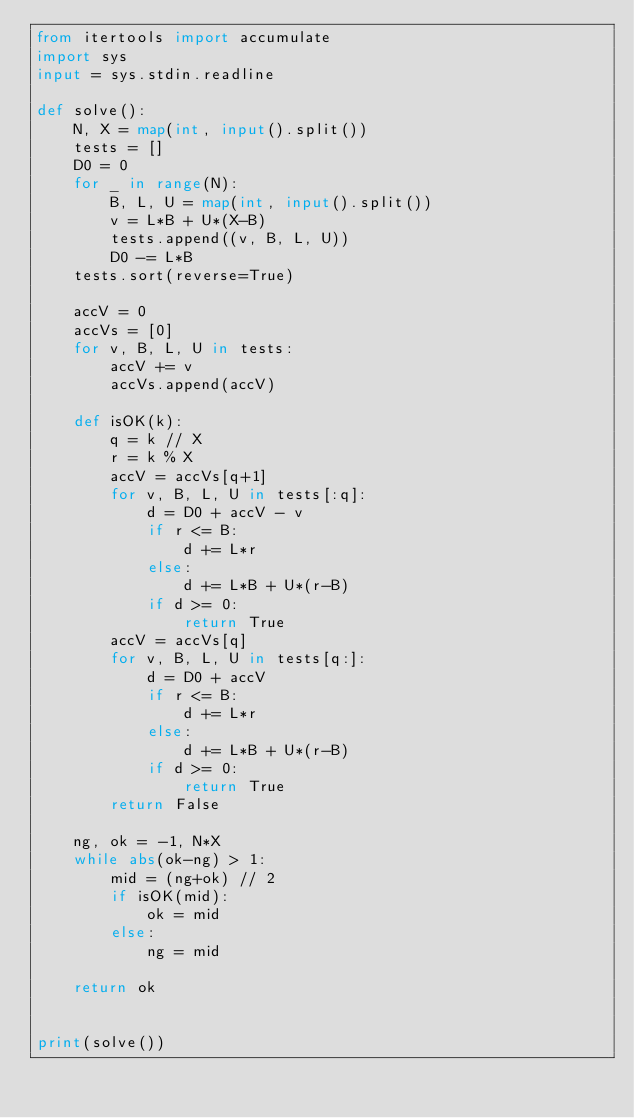<code> <loc_0><loc_0><loc_500><loc_500><_Python_>from itertools import accumulate
import sys
input = sys.stdin.readline

def solve():
    N, X = map(int, input().split())
    tests = []
    D0 = 0
    for _ in range(N):
        B, L, U = map(int, input().split())
        v = L*B + U*(X-B)
        tests.append((v, B, L, U))
        D0 -= L*B
    tests.sort(reverse=True)

    accV = 0
    accVs = [0]
    for v, B, L, U in tests:
        accV += v
        accVs.append(accV)

    def isOK(k):
        q = k // X
        r = k % X
        accV = accVs[q+1]
        for v, B, L, U in tests[:q]:
            d = D0 + accV - v
            if r <= B:
                d += L*r
            else:
                d += L*B + U*(r-B)
            if d >= 0:
                return True
        accV = accVs[q]
        for v, B, L, U in tests[q:]:
            d = D0 + accV
            if r <= B:
                d += L*r
            else:
                d += L*B + U*(r-B)
            if d >= 0:
                return True
        return False

    ng, ok = -1, N*X
    while abs(ok-ng) > 1:
        mid = (ng+ok) // 2
        if isOK(mid):
            ok = mid
        else:
            ng = mid

    return ok


print(solve())
</code> 